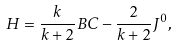<formula> <loc_0><loc_0><loc_500><loc_500>H = \frac { k } { k + 2 } B C - \frac { 2 } { k + 2 } J ^ { 0 } ,</formula> 